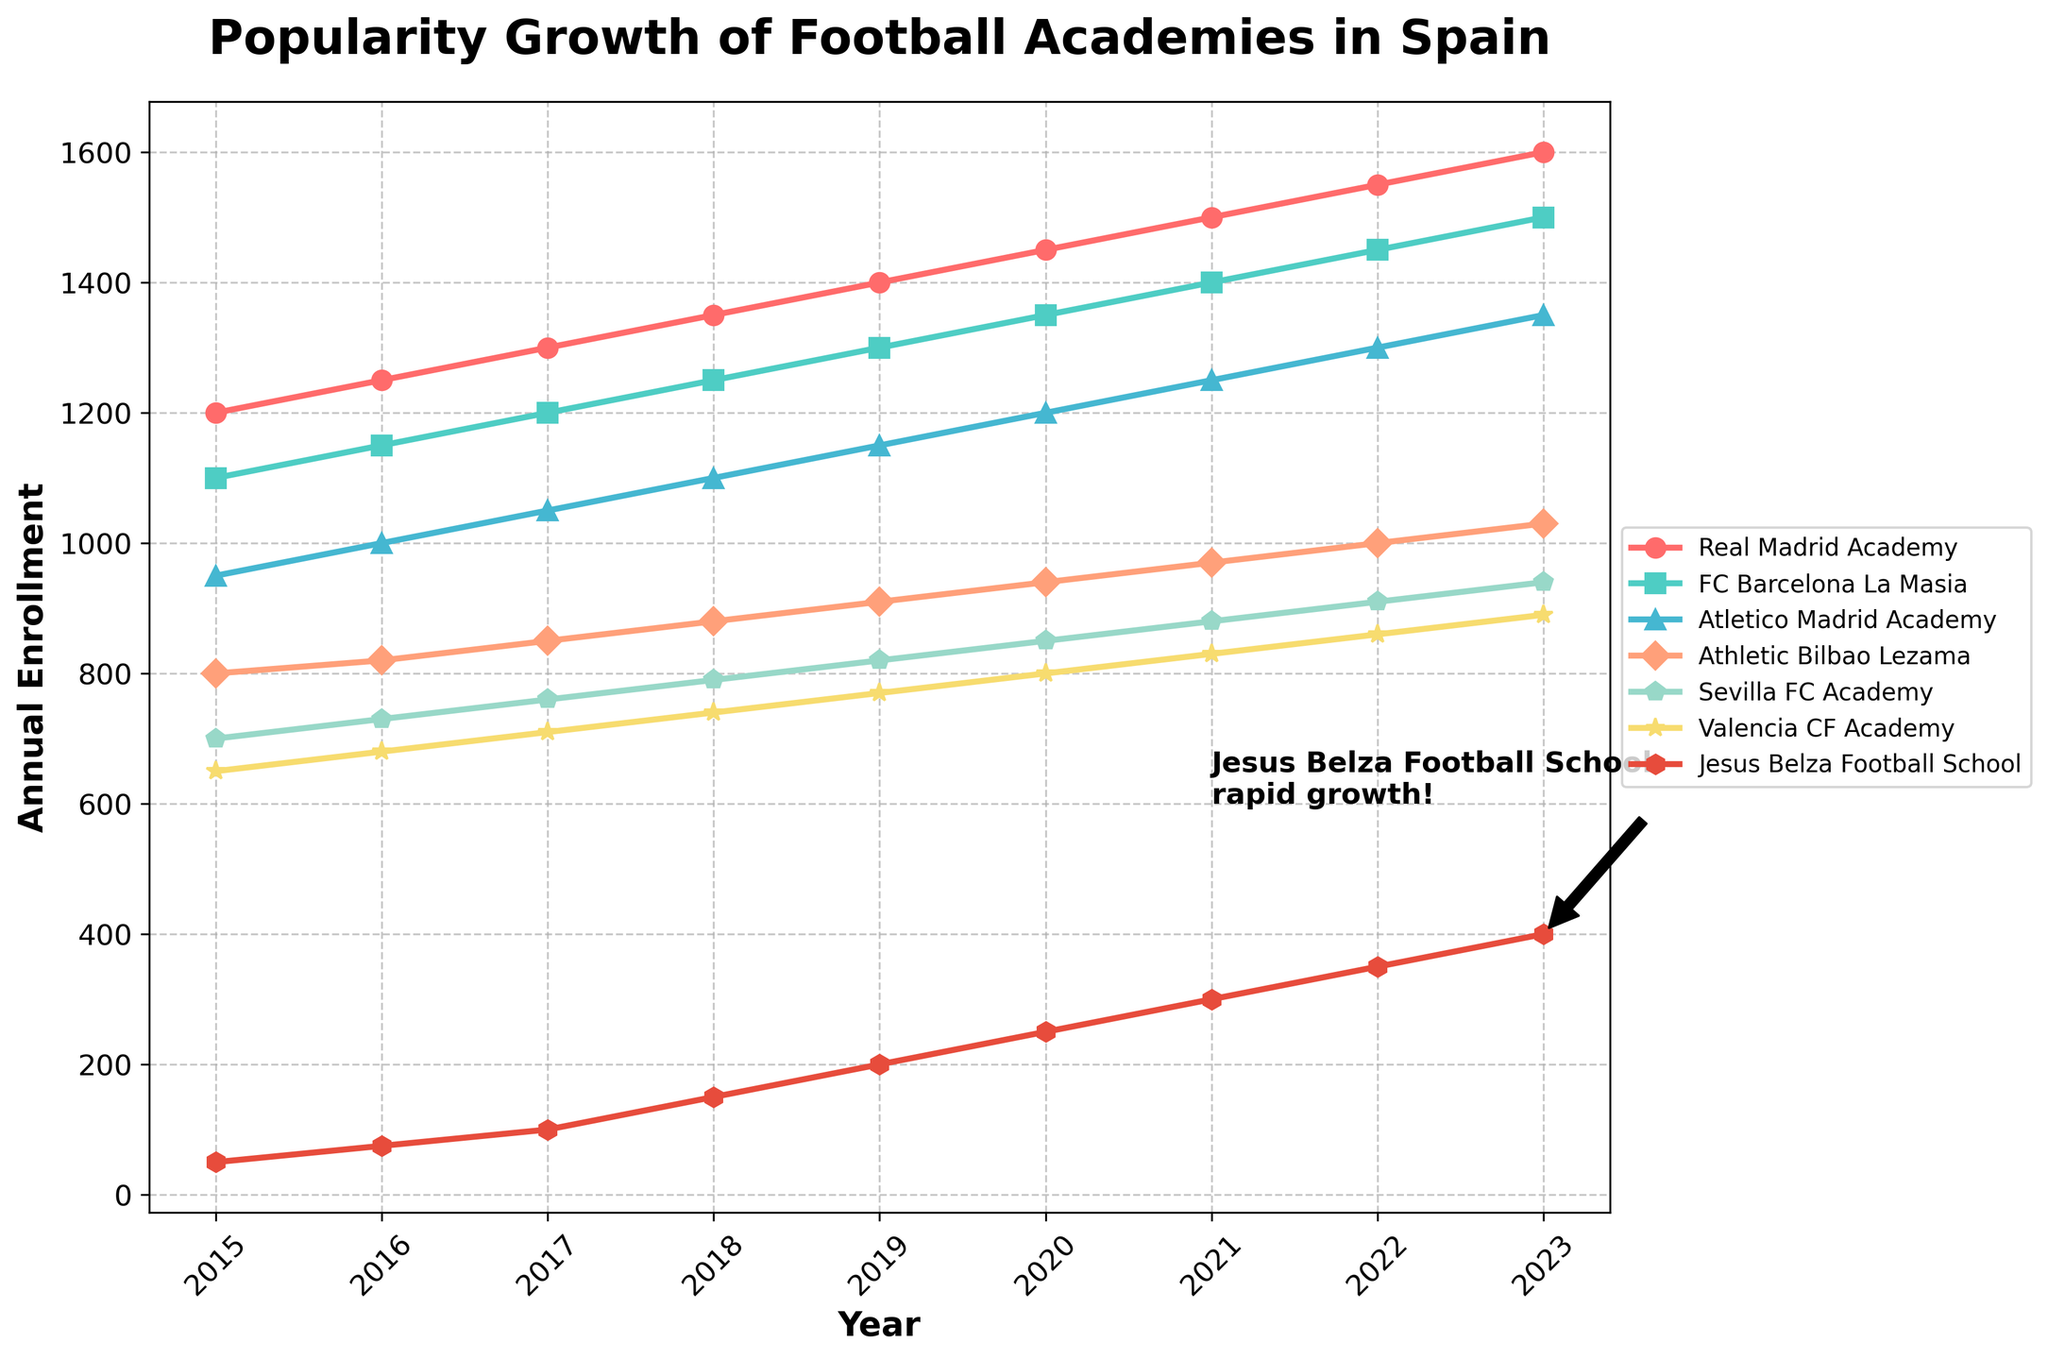Which academy had the highest enrollment in 2023? From the figure, we look at the endpoints of each line corresponding to 2023. The highest point corresponds to Real Madrid Academy with 1600 enrollments.
Answer: Real Madrid Academy How did the enrollment of Jesus Belza Football School change from 2015 to 2023? First, find the enrollment numbers for Jesus Belza Football School in 2015 (50) and 2023 (400). Calculate the difference: 400 - 50 = 350.
Answer: Increased by 350 Which two academies had the closest enrollment numbers in 2021? Check the enrollment numbers for all academies in 2021 and find the two with the smallest difference. FC Barcelona La Masia had 1400 and Real Madrid Academy had 1500, difference is 100.
Answer: FC Barcelona La Masia and Real Madrid Academy Between which two consecutive years did Sevilla FC Academy see the greatest increase in enrollment? Calculate the year-to-year differences for Sevilla FC Academy and identify the greatest increase. The greatest increase, 30 (from 910 to 940), occurred between 2022 and 2023.
Answer: 2022 and 2023 What is the average annual enrollment for Valencia CF Academy from 2015 to 2023? Sum the annual enrollments from 2015 to 2023 and divide by the number of years (9). The sum is 650 + 680 + 710 + 740 + 770 + 800 + 830 + 860 + 890 = 6930. The average is 6930 / 9 = 770.
Answer: 770 Which academy had a steeper increase in enrollment from 2015 to 2023, Atletico Madrid Academy or Athletic Bilbao Lezama? Calculate the total increase for both academies: Atletico Madrid (1350-950=400) and Athletic Bilbao Lezama (1030-800=230). Atletico Madrid Academy had a steeper increase.
Answer: Atletico Madrid Academy In what year did FC Barcelona La Masia's enrollment equal Real Madrid Academy's previous year's enrollment? Compare the enrollments: Real Madrid Academy in 2016 (1250) matches FC Barcelona La Masia in 2017 (1250).
Answer: 2017 Which academy ended with the lowest enrollment in 2023? Look at the endpoints of each line for 2023. The lowest is Jesus Belza Football School with 400 enrollments.
Answer: Jesus Belza Football School How much did the enrollment of Real Madrid Academy increase from 2017 to 2023? Subtract the 2017 value from the 2023 value for Real Madrid Academy: 1600 - 1300 = 300.
Answer: 300 